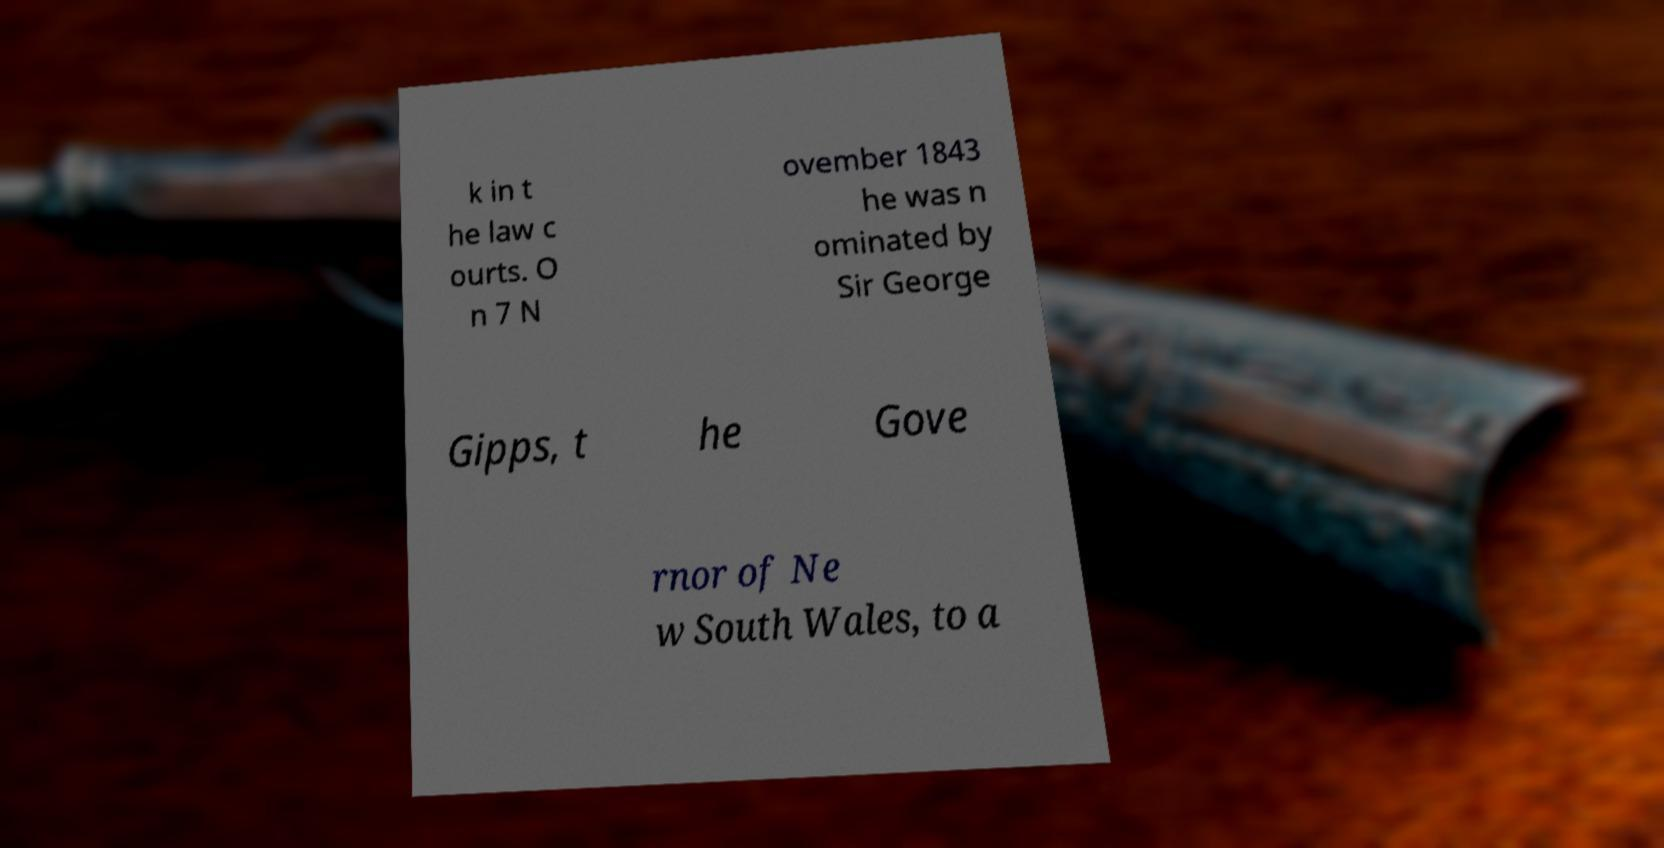Can you accurately transcribe the text from the provided image for me? k in t he law c ourts. O n 7 N ovember 1843 he was n ominated by Sir George Gipps, t he Gove rnor of Ne w South Wales, to a 